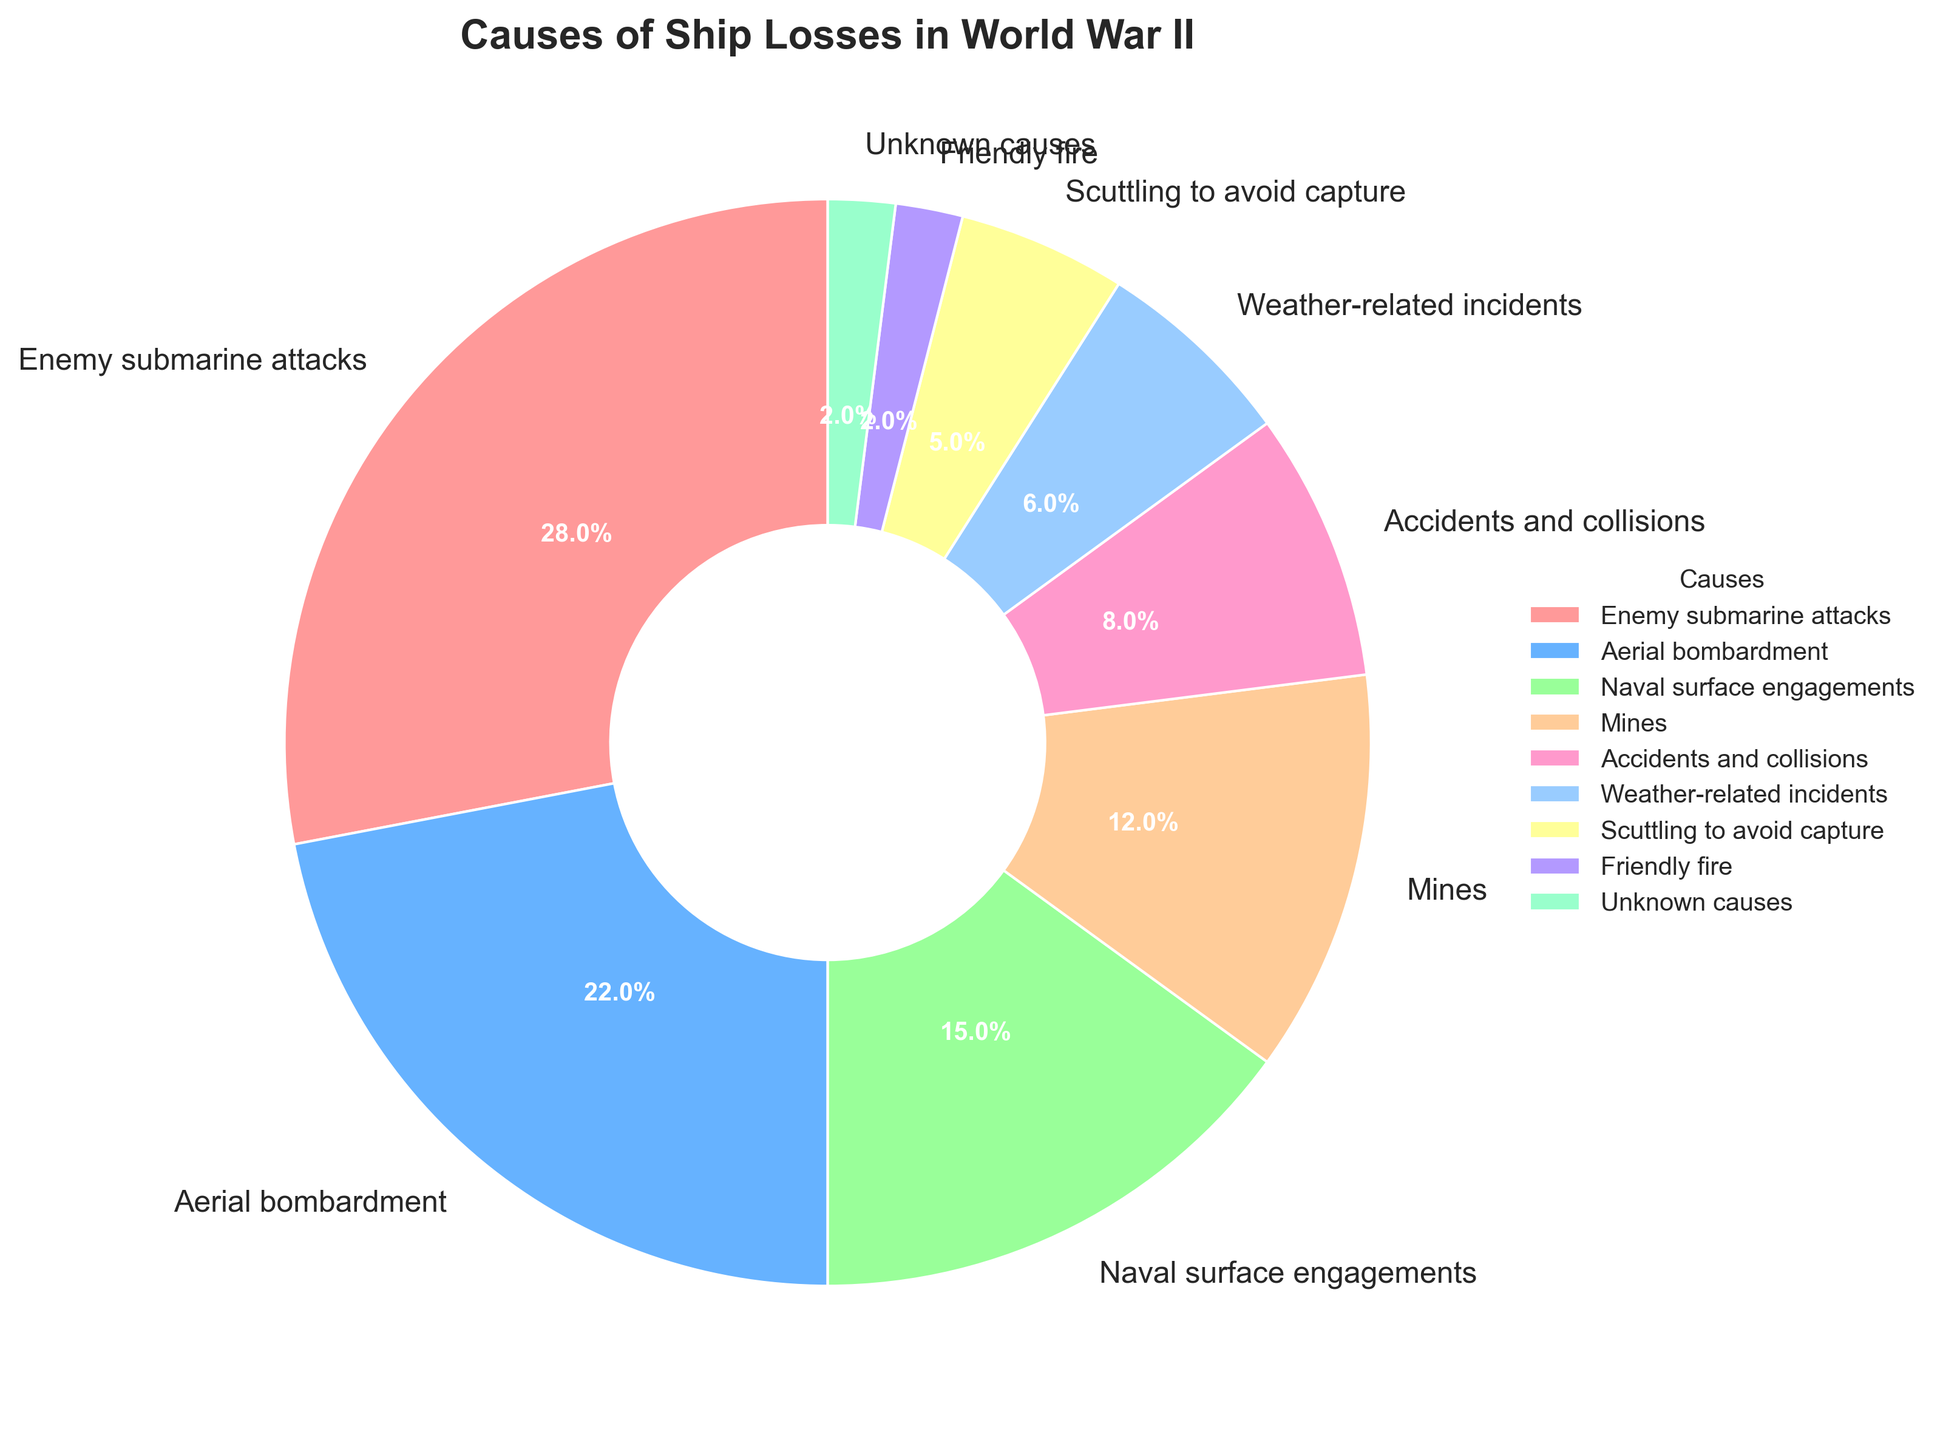What is the most common cause of ship losses during World War II? "Enemy submarine attacks" holds the highest percentage on the pie chart with 28%.
Answer: Enemy submarine attacks Which two causes combined account for over half of the ship losses? "Enemy submarine attacks" (28%) and "Aerial bombardment" (22%) together make 50%, which is over half of the ship losses.
Answer: Enemy submarine attacks and Aerial bombardment How much more significant are enemy submarine attacks compared to friendly fire incidents? Enemy submarine attacks account for 28% while friendly fire incidents account for 2%. The difference is 28% - 2% = 26%.
Answer: 26% Which cause of ship losses is the least significant? According to the pie chart, "Friendly fire" and "Unknown causes" each account for the smallest percentage of 2%.
Answer: Friendly fire and Unknown causes Is the percentage of ship losses due to accidents and collisions greater than those due to mining? The chart shows "Accidents and collisions" at 8% and "Mines" at 12%. Thus, accidents and collisions are not greater than mining-related losses.
Answer: No What is the total percentage of ship losses caused by mines, scuttling to avoid capture, and unknown causes combined? Mines (12%) + Scuttling to avoid capture (5%) + Unknown causes (2%) = 12 + 5 + 2 = 19%
Answer: 19% Which segment appears right next to "Aerial bombardment" when moving clockwise on the chart? "Aerial bombardment" is followed by "Naval surface engagements" on the pie chart.
Answer: Naval surface engagements Do weather-related incidents contribute more to ship losses than friendly fire and unknown causes combined? Weather-related incidents account for 6%. Friendly fire and unknown causes combined are 2% + 2% = 4%. Hence, weather-related incidents contribute more.
Answer: Yes What is the difference in percentage points between naval surface engagements and aerial bombardment? Naval surface engagements account for 15%, while aerial bombardment accounts for 22%. The difference is 22% - 15% = 7%.
Answer: 7% Are weather-related incidents and scuttling to avoid capture nearly equal in percentage? Weather-related incidents account for 6%, while scuttling to avoid capture accounts for 5%. The difference is 1%, making them nearly equal.
Answer: Yes 